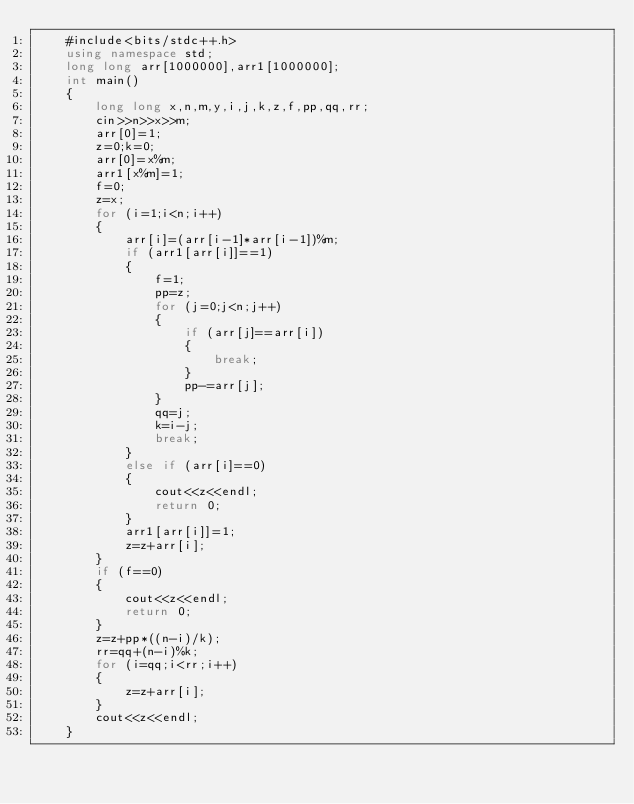Convert code to text. <code><loc_0><loc_0><loc_500><loc_500><_C++_>    #include<bits/stdc++.h>
    using namespace std;
    long long arr[1000000],arr1[1000000];
    int main()
    {
    	long long x,n,m,y,i,j,k,z,f,pp,qq,rr;
    	cin>>n>>x>>m;
    	arr[0]=1;
		z=0;k=0;
		arr[0]=x%m;
		arr1[x%m]=1;
		f=0;
		z=x;
		for (i=1;i<n;i++)
		{
			arr[i]=(arr[i-1]*arr[i-1])%m;
			if (arr1[arr[i]]==1)
			{
				f=1;
				pp=z;
				for (j=0;j<n;j++)
				{
					if (arr[j]==arr[i])
					{
						break;
					}
					pp-=arr[j];
				}
				qq=j;
				k=i-j;
				break;
			}
			else if (arr[i]==0)
			{
				cout<<z<<endl;
				return 0;
			}
			arr1[arr[i]]=1;
			z=z+arr[i];
		}
		if (f==0)
		{
			cout<<z<<endl;
			return 0;
		}
		z=z+pp*((n-i)/k);
		rr=qq+(n-i)%k;
		for (i=qq;i<rr;i++)
		{
			z=z+arr[i];
		}
		cout<<z<<endl;
    }</code> 